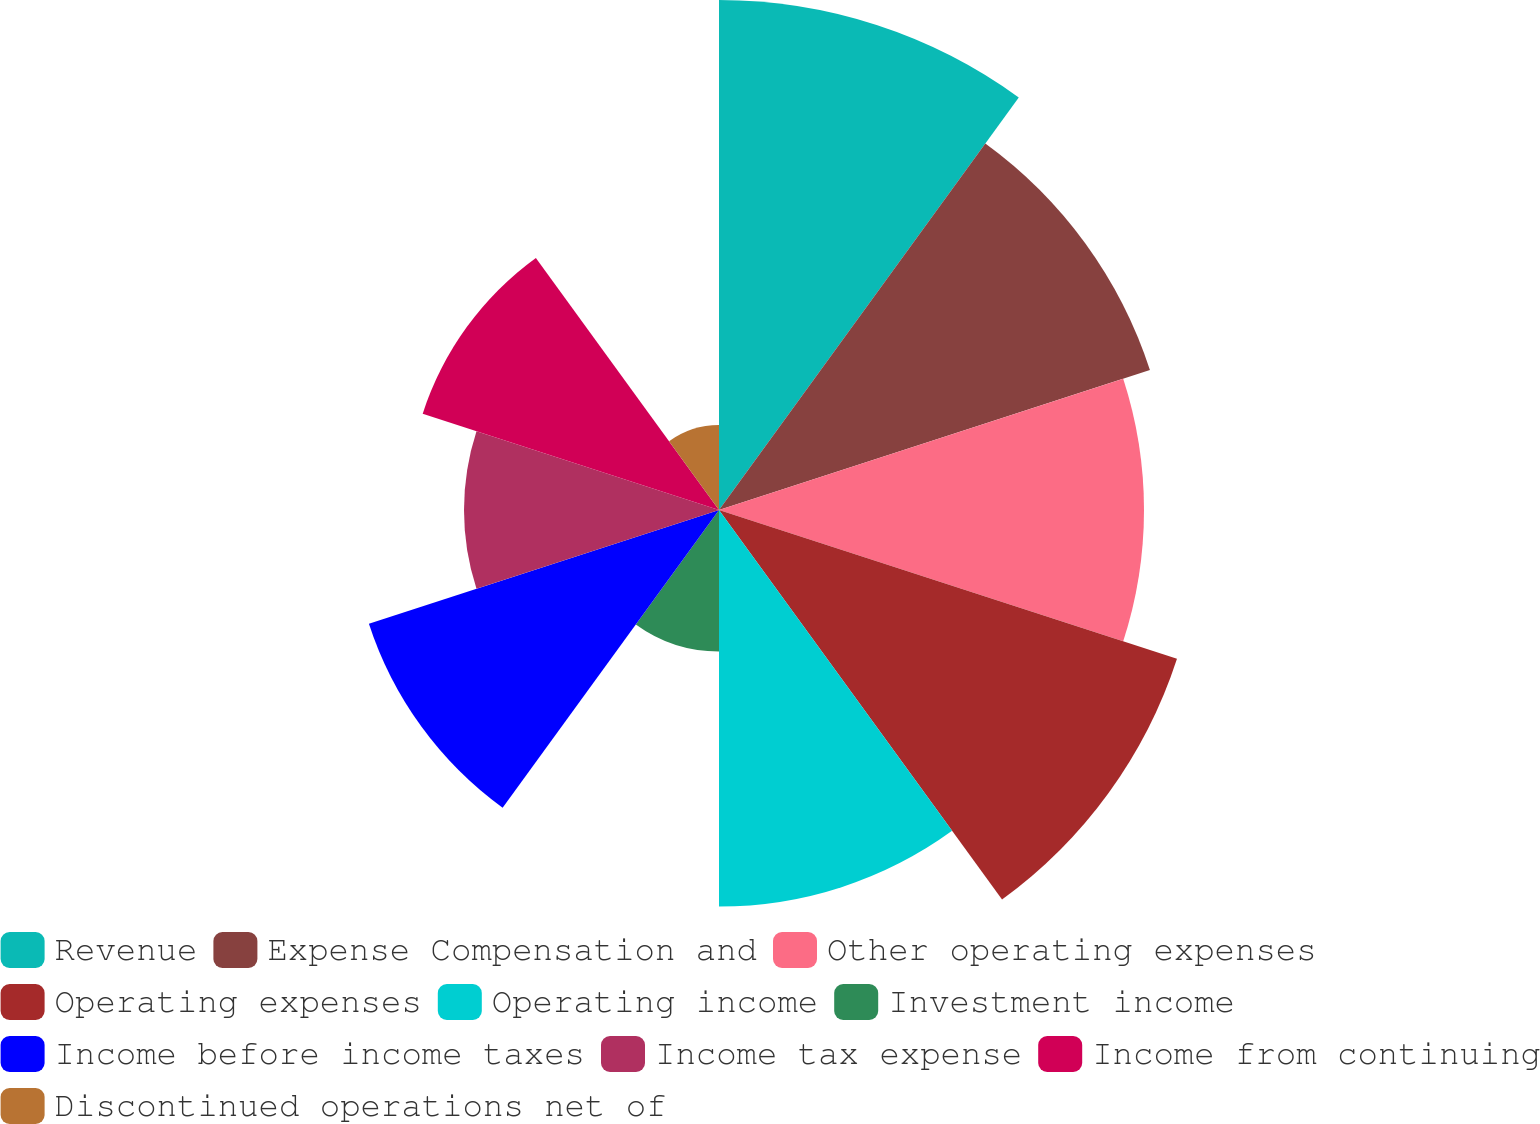Convert chart to OTSL. <chart><loc_0><loc_0><loc_500><loc_500><pie_chart><fcel>Revenue<fcel>Expense Compensation and<fcel>Other operating expenses<fcel>Operating expenses<fcel>Operating income<fcel>Investment income<fcel>Income before income taxes<fcel>Income tax expense<fcel>Income from continuing<fcel>Discontinued operations net of<nl><fcel>14.88%<fcel>13.22%<fcel>12.4%<fcel>14.05%<fcel>11.57%<fcel>4.13%<fcel>10.74%<fcel>7.44%<fcel>9.09%<fcel>2.48%<nl></chart> 